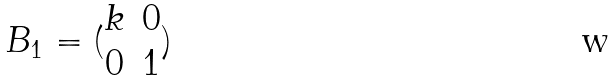<formula> <loc_0><loc_0><loc_500><loc_500>B _ { 1 } = ( \begin{matrix} k & 0 \\ 0 & 1 \end{matrix} )</formula> 